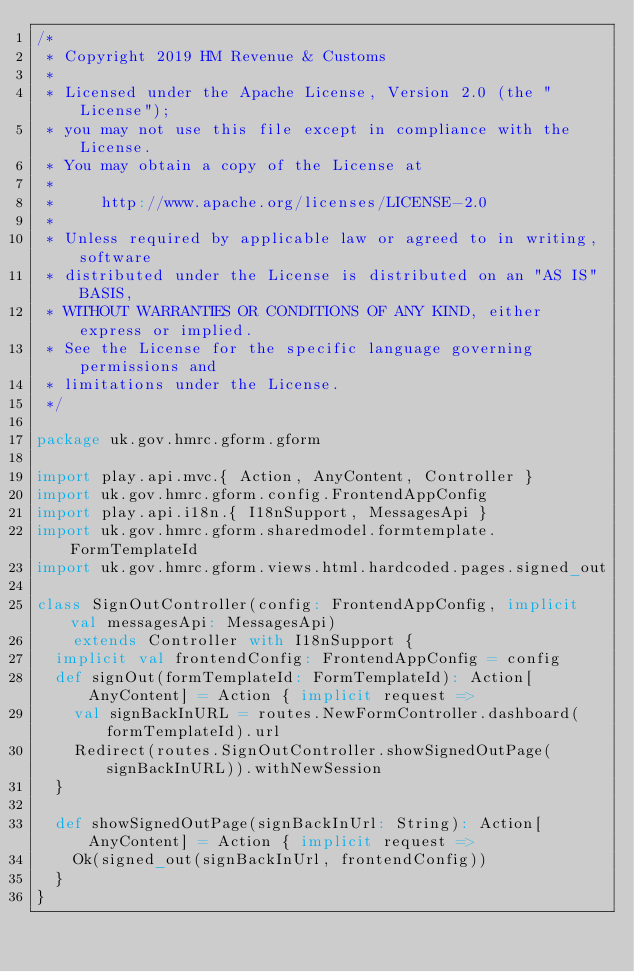<code> <loc_0><loc_0><loc_500><loc_500><_Scala_>/*
 * Copyright 2019 HM Revenue & Customs
 *
 * Licensed under the Apache License, Version 2.0 (the "License");
 * you may not use this file except in compliance with the License.
 * You may obtain a copy of the License at
 *
 *     http://www.apache.org/licenses/LICENSE-2.0
 *
 * Unless required by applicable law or agreed to in writing, software
 * distributed under the License is distributed on an "AS IS" BASIS,
 * WITHOUT WARRANTIES OR CONDITIONS OF ANY KIND, either express or implied.
 * See the License for the specific language governing permissions and
 * limitations under the License.
 */

package uk.gov.hmrc.gform.gform

import play.api.mvc.{ Action, AnyContent, Controller }
import uk.gov.hmrc.gform.config.FrontendAppConfig
import play.api.i18n.{ I18nSupport, MessagesApi }
import uk.gov.hmrc.gform.sharedmodel.formtemplate.FormTemplateId
import uk.gov.hmrc.gform.views.html.hardcoded.pages.signed_out

class SignOutController(config: FrontendAppConfig, implicit val messagesApi: MessagesApi)
    extends Controller with I18nSupport {
  implicit val frontendConfig: FrontendAppConfig = config
  def signOut(formTemplateId: FormTemplateId): Action[AnyContent] = Action { implicit request =>
    val signBackInURL = routes.NewFormController.dashboard(formTemplateId).url
    Redirect(routes.SignOutController.showSignedOutPage(signBackInURL)).withNewSession
  }

  def showSignedOutPage(signBackInUrl: String): Action[AnyContent] = Action { implicit request =>
    Ok(signed_out(signBackInUrl, frontendConfig))
  }
}
</code> 